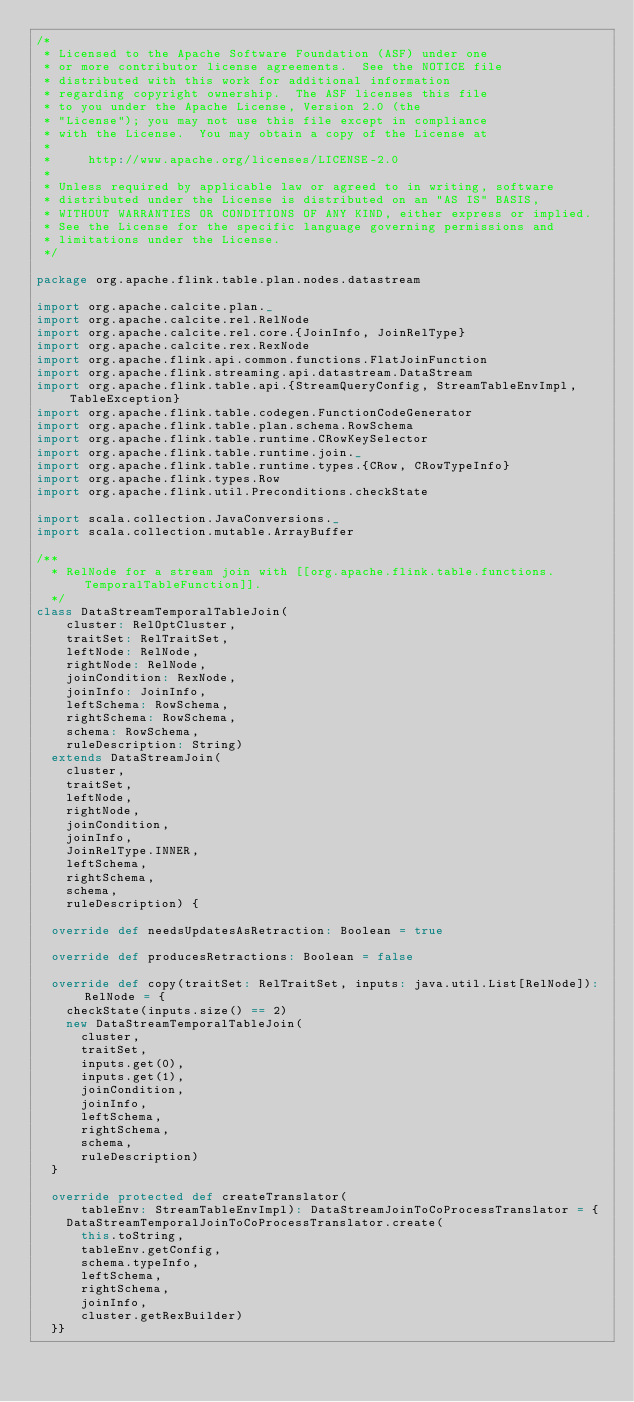Convert code to text. <code><loc_0><loc_0><loc_500><loc_500><_Scala_>/*
 * Licensed to the Apache Software Foundation (ASF) under one
 * or more contributor license agreements.  See the NOTICE file
 * distributed with this work for additional information
 * regarding copyright ownership.  The ASF licenses this file
 * to you under the Apache License, Version 2.0 (the
 * "License"); you may not use this file except in compliance
 * with the License.  You may obtain a copy of the License at
 *
 *     http://www.apache.org/licenses/LICENSE-2.0
 *
 * Unless required by applicable law or agreed to in writing, software
 * distributed under the License is distributed on an "AS IS" BASIS,
 * WITHOUT WARRANTIES OR CONDITIONS OF ANY KIND, either express or implied.
 * See the License for the specific language governing permissions and
 * limitations under the License.
 */

package org.apache.flink.table.plan.nodes.datastream

import org.apache.calcite.plan._
import org.apache.calcite.rel.RelNode
import org.apache.calcite.rel.core.{JoinInfo, JoinRelType}
import org.apache.calcite.rex.RexNode
import org.apache.flink.api.common.functions.FlatJoinFunction
import org.apache.flink.streaming.api.datastream.DataStream
import org.apache.flink.table.api.{StreamQueryConfig, StreamTableEnvImpl, TableException}
import org.apache.flink.table.codegen.FunctionCodeGenerator
import org.apache.flink.table.plan.schema.RowSchema
import org.apache.flink.table.runtime.CRowKeySelector
import org.apache.flink.table.runtime.join._
import org.apache.flink.table.runtime.types.{CRow, CRowTypeInfo}
import org.apache.flink.types.Row
import org.apache.flink.util.Preconditions.checkState

import scala.collection.JavaConversions._
import scala.collection.mutable.ArrayBuffer

/**
  * RelNode for a stream join with [[org.apache.flink.table.functions.TemporalTableFunction]].
  */
class DataStreamTemporalTableJoin(
    cluster: RelOptCluster,
    traitSet: RelTraitSet,
    leftNode: RelNode,
    rightNode: RelNode,
    joinCondition: RexNode,
    joinInfo: JoinInfo,
    leftSchema: RowSchema,
    rightSchema: RowSchema,
    schema: RowSchema,
    ruleDescription: String)
  extends DataStreamJoin(
    cluster,
    traitSet,
    leftNode,
    rightNode,
    joinCondition,
    joinInfo,
    JoinRelType.INNER,
    leftSchema,
    rightSchema,
    schema,
    ruleDescription) {

  override def needsUpdatesAsRetraction: Boolean = true

  override def producesRetractions: Boolean = false

  override def copy(traitSet: RelTraitSet, inputs: java.util.List[RelNode]): RelNode = {
    checkState(inputs.size() == 2)
    new DataStreamTemporalTableJoin(
      cluster,
      traitSet,
      inputs.get(0),
      inputs.get(1),
      joinCondition,
      joinInfo,
      leftSchema,
      rightSchema,
      schema,
      ruleDescription)
  }

  override protected def createTranslator(
      tableEnv: StreamTableEnvImpl): DataStreamJoinToCoProcessTranslator = {
    DataStreamTemporalJoinToCoProcessTranslator.create(
      this.toString,
      tableEnv.getConfig,
      schema.typeInfo,
      leftSchema,
      rightSchema,
      joinInfo,
      cluster.getRexBuilder)
  }}
</code> 